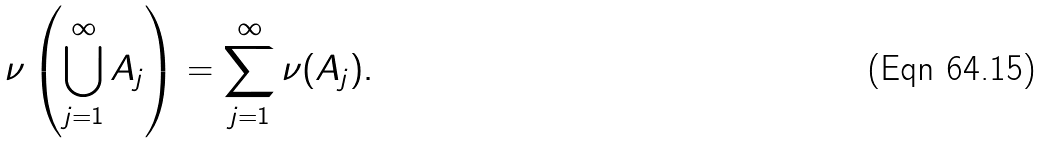<formula> <loc_0><loc_0><loc_500><loc_500>\nu \left ( \bigcup _ { j = 1 } ^ { \infty } A _ { j } \right ) = \sum _ { j = 1 } ^ { \infty } \nu ( A _ { j } ) .</formula> 